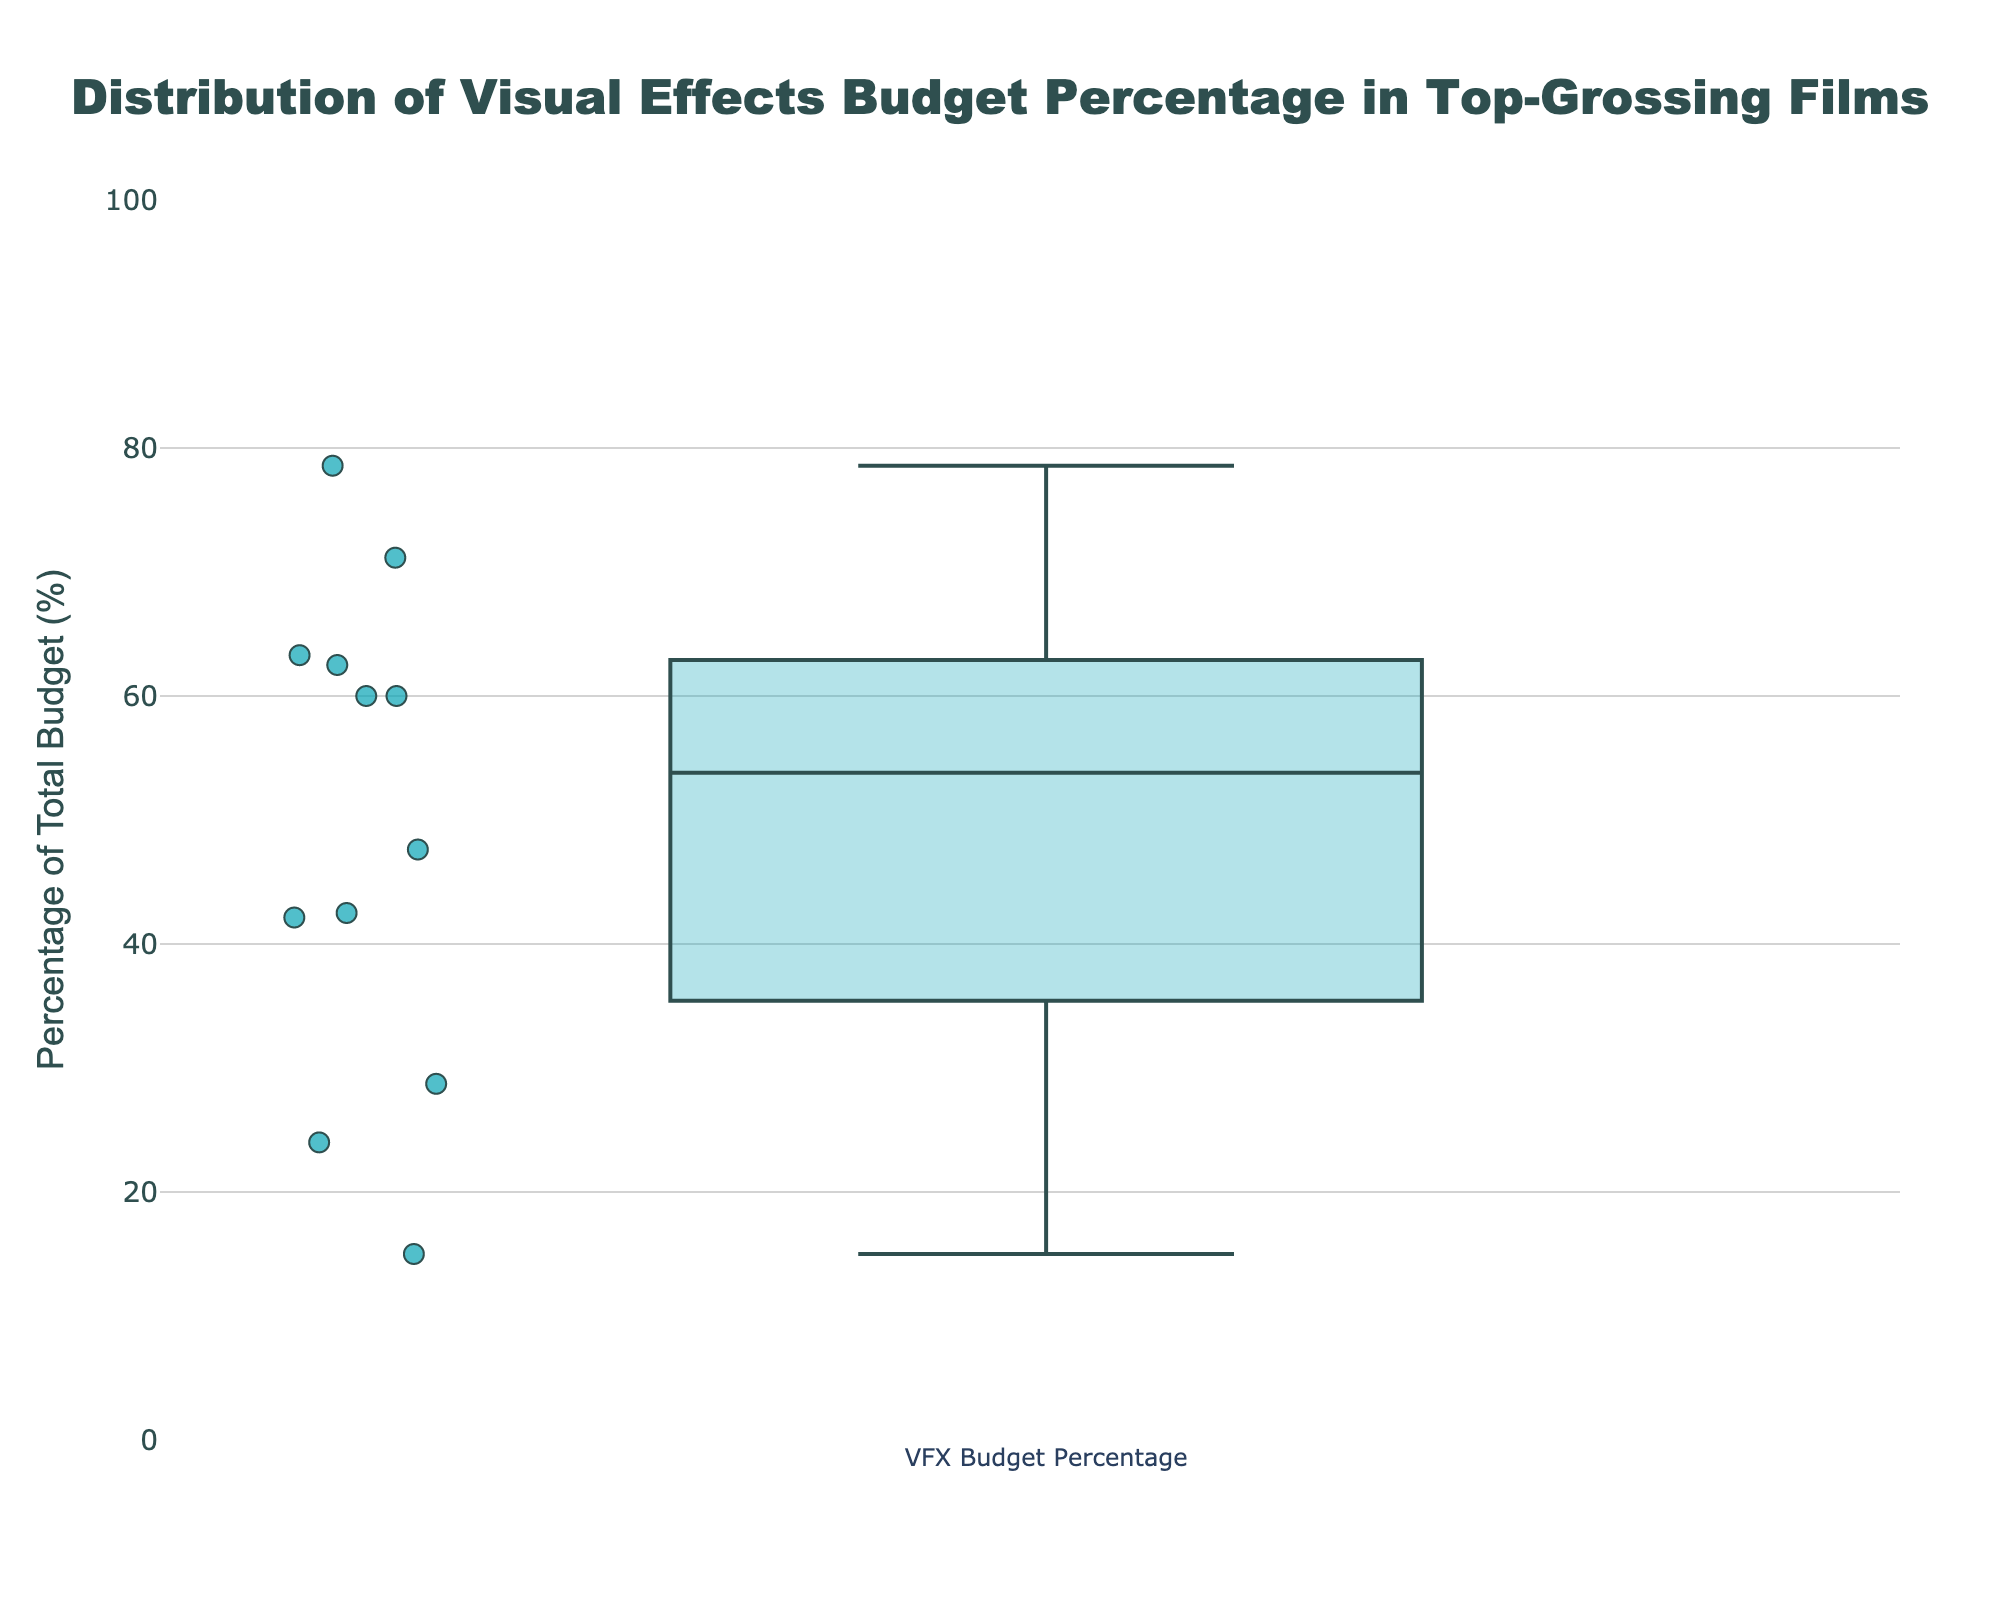How many film titles are included in the box plot? There are a total of 12 data points in the box plot, each representing a distinct film title. This can be counted by looking at the data points displayed in the plot and the hover information.
Answer: 12 What is the title of the box plot? The title of the box plot is displayed at the top of the figure as 'Distribution of Visual Effects Budget Percentage in Top-Grossing Films'.
Answer: Distribution of Visual Effects Budget Percentage in Top-Grossing Films Which film has the highest percentage of its budget allocated to visual effects? By hovering over the data points in the box plot, we can identify the film with the highest percentage of visual effects budget. The Lion King has the highest percentage, closely followed by Avatar and Avengers: Endgame.
Answer: The Lion King What's the median percentage of the visual effects budget? The median of a box plot is indicated by the line inside the box. By observing the line, we estimate the median percentage of the visual effects budget which is around 60%.
Answer: 60% Are there any outliers in the visual effects budget percentage, and if so, which films do they correspond to? Outliers in a box plot are represented by points outside the range of the whiskers. By examining the plot, we see that The Lion King and Titanic vary notably from the others.
Answer: The Lion King, Titanic What is the interquartile range (IQR) of the visual effects budget percentage? The IQR is the range between the first (Q1) and third quartile (Q3) of the data, represented by the edges of the box. By estimating from the plot, Q1 is around 25% and Q3 is around 75%. Hence, IQR = Q3 - Q1.
Answer: 50% Which films allocate less than 30% of their total budget to visual effects? By examining the points below the 30% mark on the y-axis, we can see that The Matrix, The Lord of the Rings: The Two Towers, and Titanic allocate less than 30% of their budget to visual effects.
Answer: The Matrix, The Lord of the Rings: The Two Towers, Titanic How does the visual effects budget percentage vary between science fiction and fantasy genres? By looking at data points for films under these genres (science fiction: Avatar, Inception, Star Wars: The Last Jedi, The Matrix, fantasy: The Lord of the Rings: The Two Towers), we observe that generally, science fiction films allocate a higher percentage of their budget to visual effects compared to fantasy films.
Answer: Higher in science fiction What is the range of visual effects budget percentages from the minimum to the maximum value? The range can be found by subtracting the minimum value from the maximum value. Based on the plot, the maximum percentage is around 71% and the minimum is around 13%. So, the range = 71% - 13%.
Answer: 58% Are there more films that allocate more than 50% or less than 50% of their budget to visual effects? By examining the median line in the box plot which is around 60%, we see that more films have allocated more than 50% of their total budget to visual effects.
Answer: More than 50% 